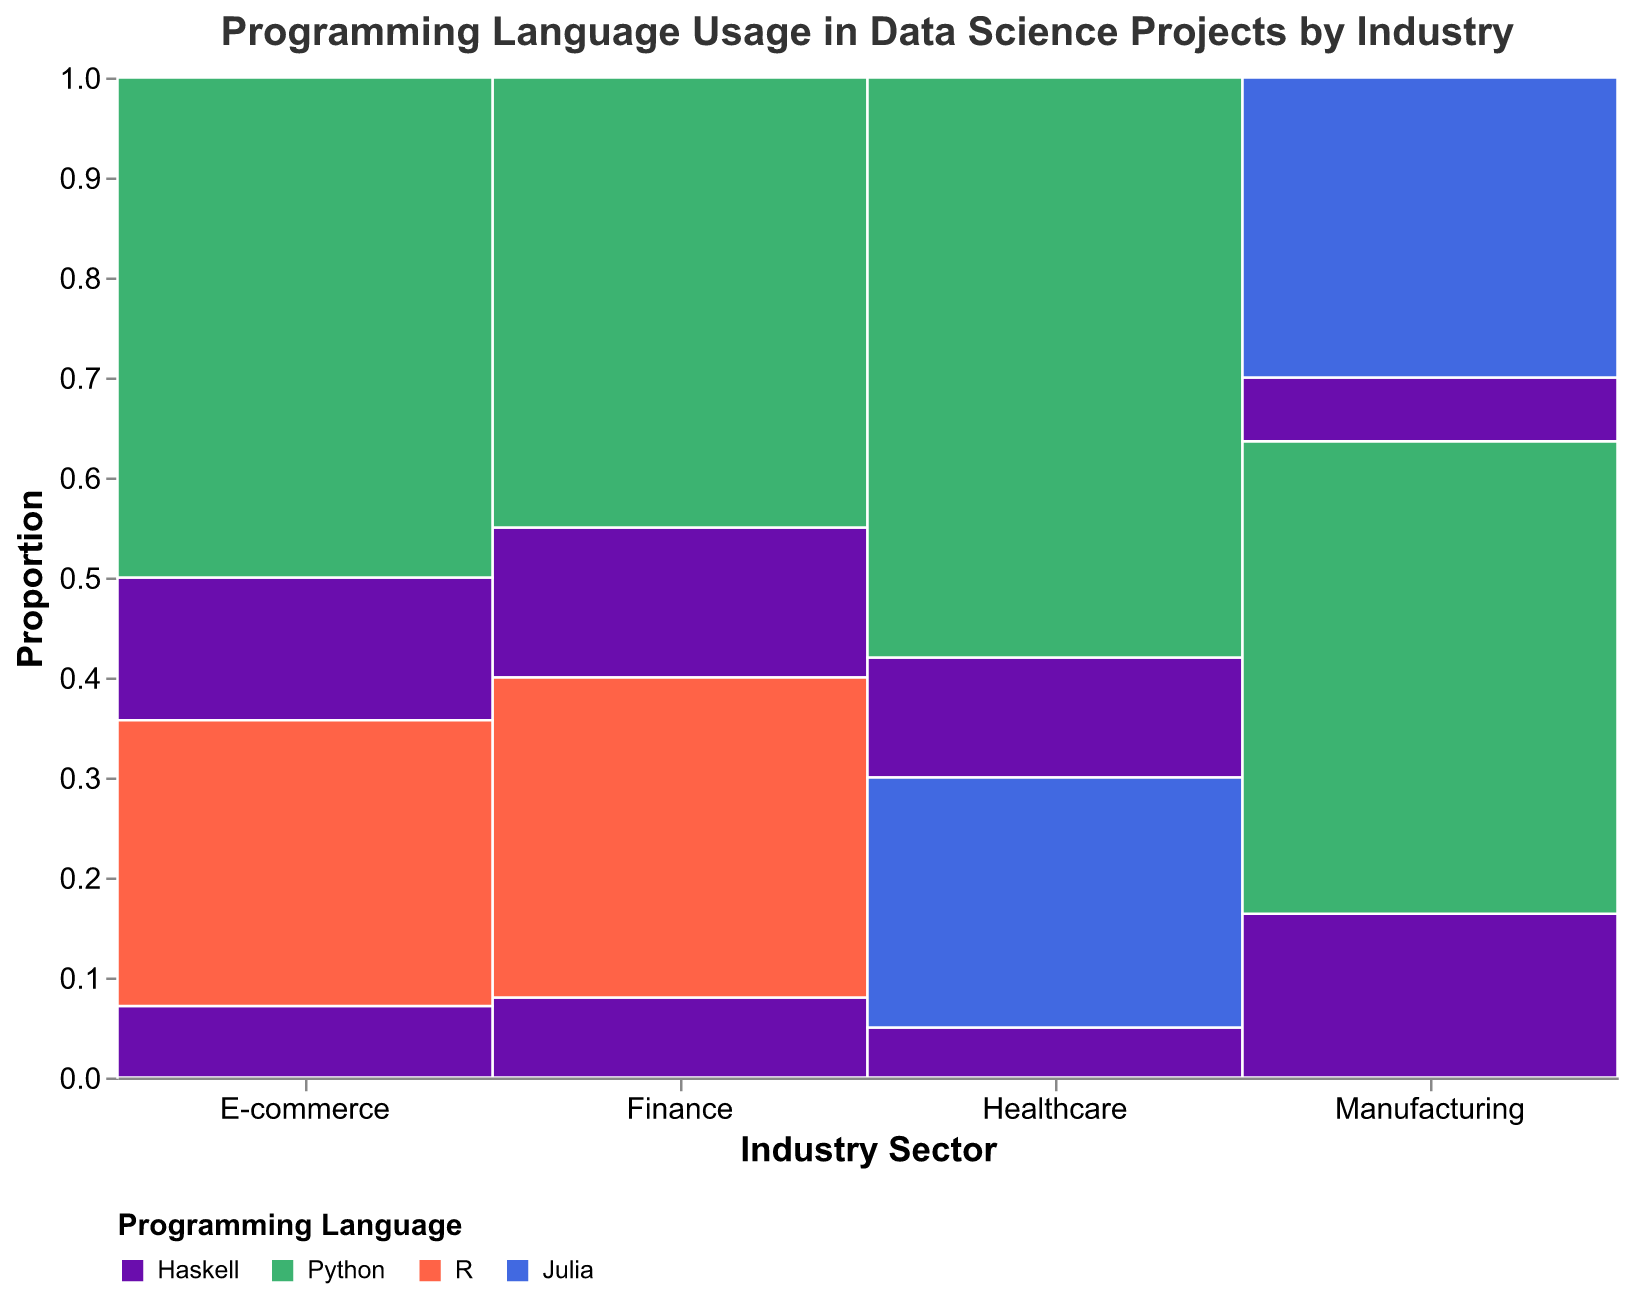Which industry has the highest proportion of Python usage? To determine this, observe the height of the green section (representing Python) on the y-axis for each industry. The E-commerce industry shows the highest section of green.
Answer: E-commerce What is the total count of projects using Haskell in the Healthcare industry? Look at the Healthcare industry section and sum the counts for Haskell in both project types (12 for Patient Outcome Prediction + 5 for Medical Image Analysis).
Answer: 17 Which project type within the Finance industry has a higher usage of R, and what are the counts? Identify the project types within the Finance sector and compare the usage of R (indicated by orange). Fraud Detection shows usage of R with a count of 32, while Risk Modeling does not have any R usage.
Answer: Fraud Detection, 32 How does Haskell's usage in Predictive Maintenance compare to its usage in Quality Control within the Manufacturing industry? Compare the counts of Haskell usage in these two project types. Predictive Maintenance has 18 Haskell projects, while Quality Control has 7.
Answer: Predictive Maintenance usage is higher In which industry is Julia used and in what project types? Look for the blue sections and check the project types within those industries. Healthcare (Medical Image Analysis) and Manufacturing (Quality Control) show Julia usage.
Answer: Healthcare (Medical Image Analysis) and Manufacturing (Quality Control) Which project type within the E-commerce industry has the highest overall project count? In the E-commerce industry section, compare the total heights of the segments for each project type. Recommendation Systems has higher total counts.
Answer: Recommendation Systems What are the relative proportions of Haskell usage between Healthcare and Finance industries? Compare the height of the purple (Haskell) segments within both industries. In Healthcare, the segments are smaller compared to Finance.
Answer: Higher in Finance What is the combined proportion of Python usage across all industries? Sum the height of the green sections in all industry segments and compare it to the total height of all sections.
Answer: Analyzing the visual data, it is the highest among all languages Which industry has the most diverse usage of different programming languages across project types? Look for the industry with the most varied colors within its segments. Manufacturing shows a mix of Haskell, Python, and Julia.
Answer: Manufacturing 